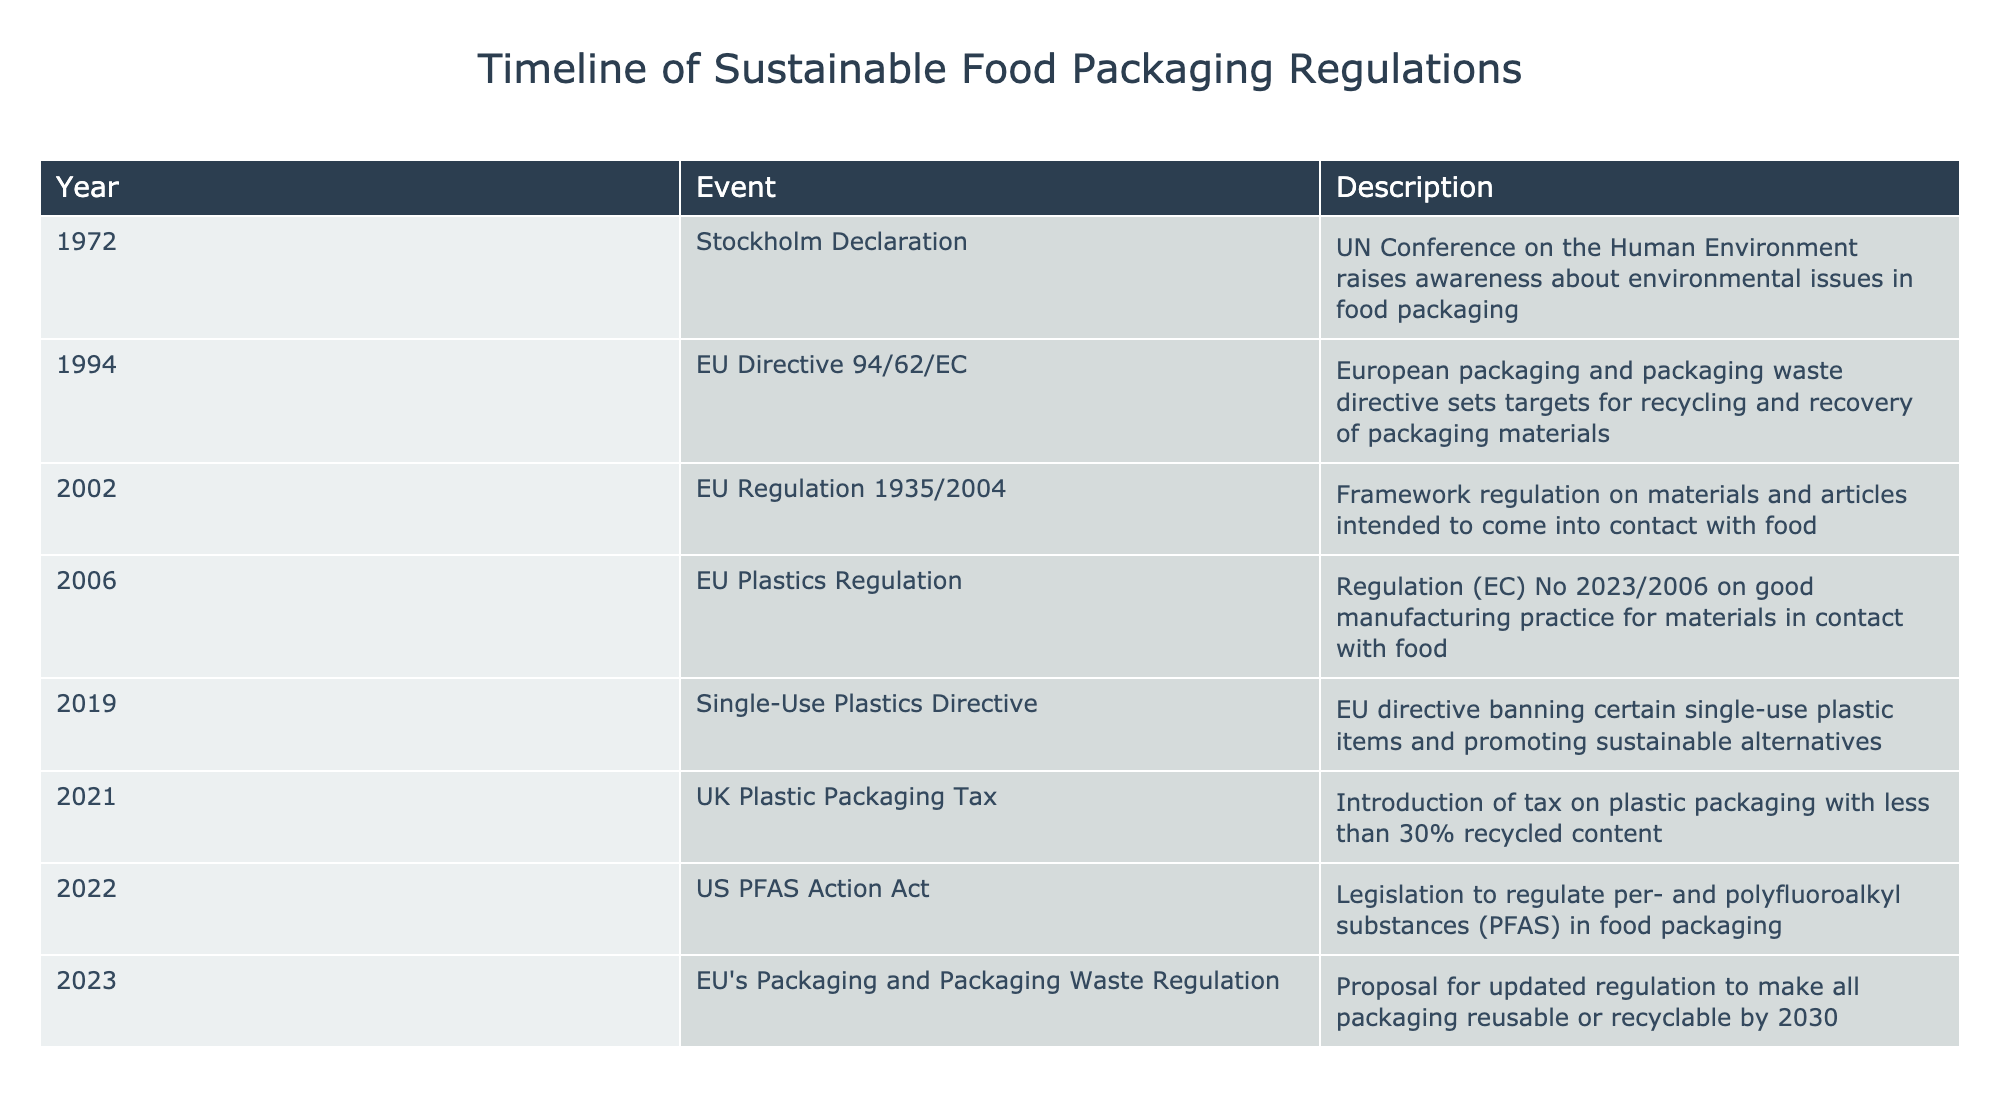What event raised awareness about environmental issues in food packaging? The table shows that the Stockholm Declaration in 1972 was the event that raised awareness about environmental issues in food packaging.
Answer: Stockholm Declaration Which regulation was enacted in 2002 regarding materials intended for contact with food? According to the table, EU Regulation 1935/2004, enacted in 2002, is the framework regulation on materials and articles intended to come into contact with food.
Answer: EU Regulation 1935/2004 Did the Single-Use Plastics Directive promote sustainable alternatives? The description of the Single-Use Plastics Directive in 2019 states that it bans certain single-use plastic items and promotes sustainable alternatives, so the answer is yes.
Answer: Yes How many years passed between the Stockholm Declaration and the introduction of the UK Plastic Packaging Tax? To find the number of years, we subtract the year of the Stockholm Declaration (1972) from the year of the UK Plastic Packaging Tax (2021). The calculation is 2021 - 1972 = 49 years.
Answer: 49 years In what year did the EU propose the updated Packaging and Packaging Waste Regulation? The table indicates that the EU's Packaging and Packaging Waste Regulation was proposed in 2023.
Answer: 2023 What percentage of recycled content must plastic packaging have to avoid the UK Plastic Packaging Tax? The table states that the UK Plastic Packaging Tax applies to plastic packaging with less than 30% recycled content, indicating that 30% is the threshold to avoid the tax.
Answer: 30% Which event marked a significant shift towards banning certain single-use plastics in the EU? The Single-Use Plastics Directive in 2019 marked a significant shift as it specifically banned certain single-use plastic items in the EU.
Answer: Single-Use Plastics Directive List all the regulations that aim to regulate materials that come into contact with food. The table lists two regulations: EU Regulation 1935/2004 (2002) and EU Plastics Regulation (2006) that both focus on materials in contact with food.
Answer: EU Regulation 1935/2004 and EU Plastics Regulation How many events took place in the 2000s related to sustainable food packaging regulations? Referring to the table, there are three events in the 2000s: EU Regulation 1935/2004 (2002), EU Plastics Regulation (2006), and the Single-Use Plastics Directive (2019). Therefore, the count is 3 events.
Answer: 3 events 